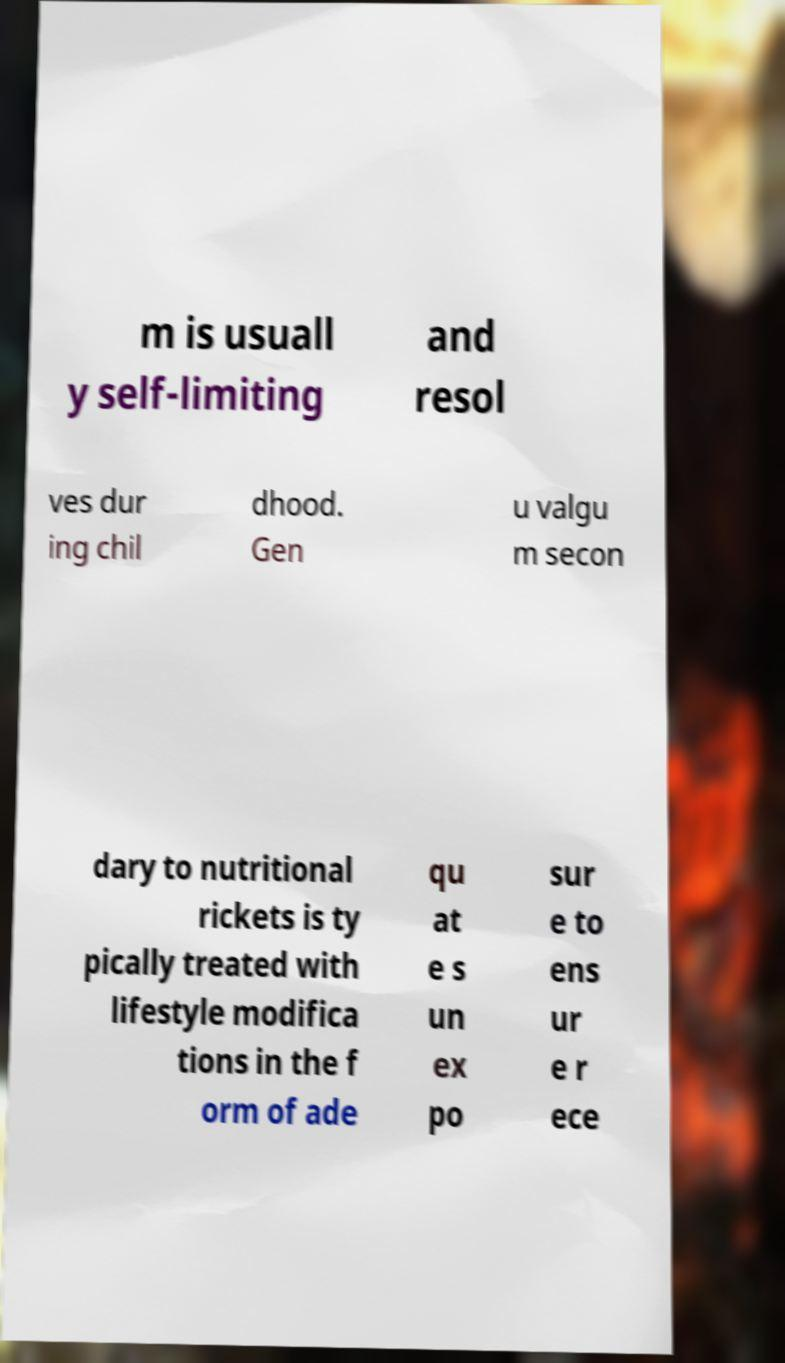Could you extract and type out the text from this image? m is usuall y self-limiting and resol ves dur ing chil dhood. Gen u valgu m secon dary to nutritional rickets is ty pically treated with lifestyle modifica tions in the f orm of ade qu at e s un ex po sur e to ens ur e r ece 